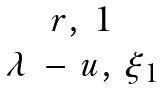<formula> <loc_0><loc_0><loc_500><loc_500>\begin{matrix} r , \, 1 \\ \lambda \, - \, u , \, \xi _ { 1 } \end{matrix}</formula> 